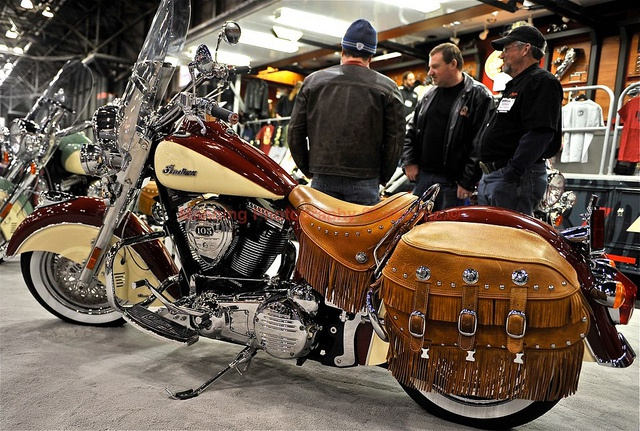Describe the objects in this image and their specific colors. I can see motorcycle in black, maroon, gray, and darkgray tones, people in black, gray, and darkgray tones, people in black, gray, maroon, and white tones, people in black, gray, maroon, and brown tones, and motorcycle in black, gray, darkgray, and lightgray tones in this image. 